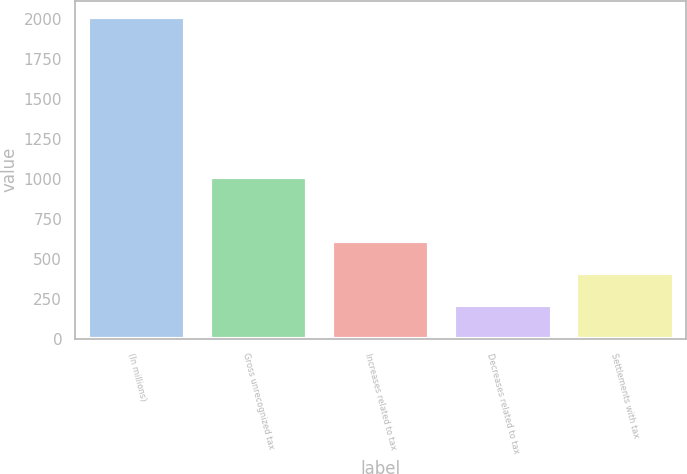Convert chart. <chart><loc_0><loc_0><loc_500><loc_500><bar_chart><fcel>(In millions)<fcel>Gross unrecognized tax<fcel>Increases related to tax<fcel>Decreases related to tax<fcel>Settlements with tax<nl><fcel>2016<fcel>1011.5<fcel>609.7<fcel>207.9<fcel>408.8<nl></chart> 